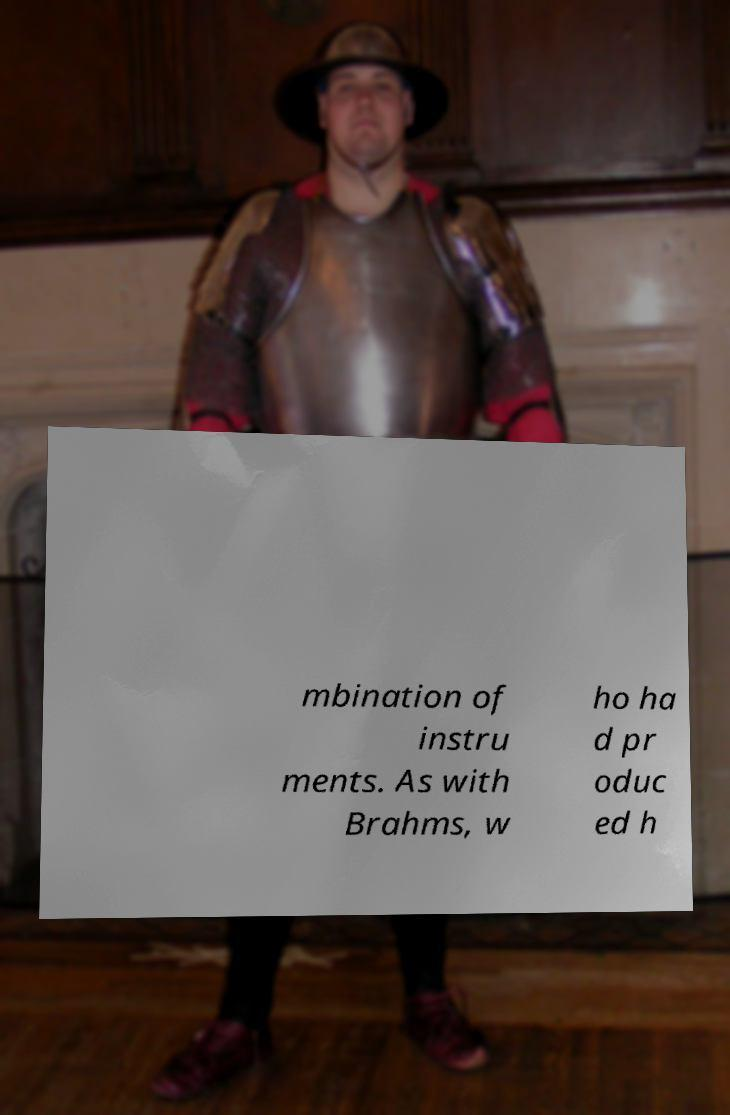Please identify and transcribe the text found in this image. mbination of instru ments. As with Brahms, w ho ha d pr oduc ed h 